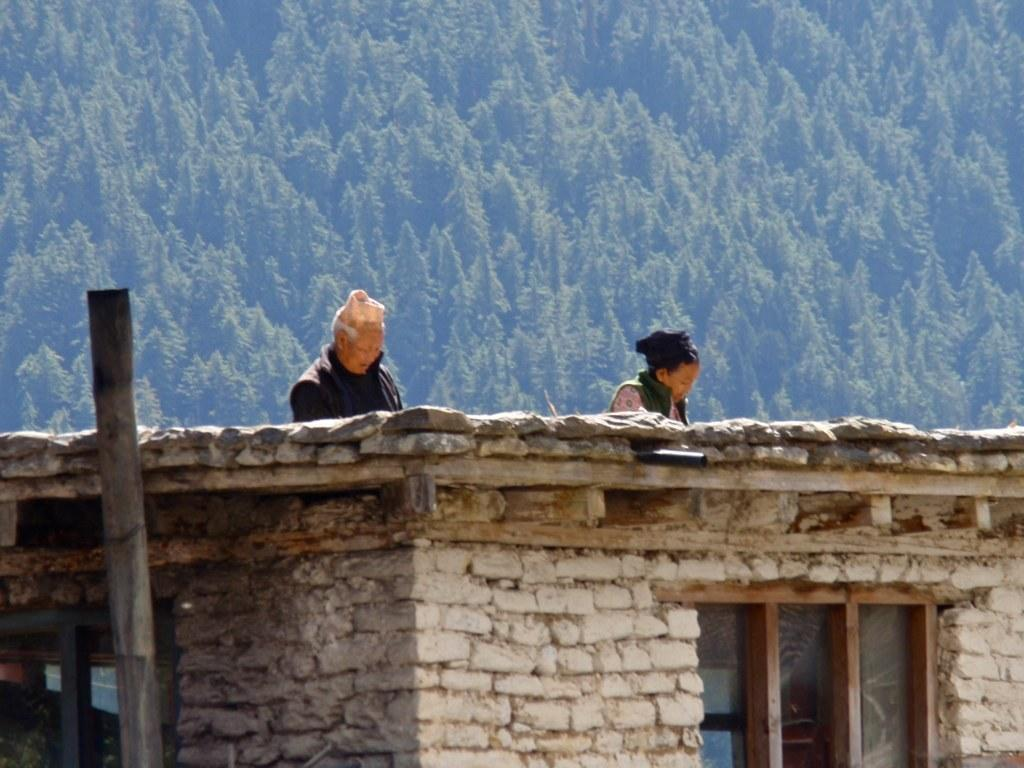What type of house is in the image? There is a brick house in the image. What feature of the house is visible in the image? There is a window in the image. Who is on top of the house in the image? There is a man and a woman on the top of the house. What can be seen in the background of the image? Trees are present in the background of the image. What type of juice is being served to the fowl in the image? There is no juice or fowl present in the image. What rhythm are the people on the roof dancing to in the image? There is no dancing or rhythm mentioned in the image; the man and woman are simply standing on top of the house. 